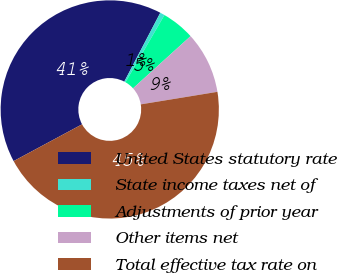<chart> <loc_0><loc_0><loc_500><loc_500><pie_chart><fcel>United States statutory rate<fcel>State income taxes net of<fcel>Adjustments of prior year<fcel>Other items net<fcel>Total effective tax rate on<nl><fcel>40.51%<fcel>0.69%<fcel>4.92%<fcel>9.14%<fcel>44.73%<nl></chart> 